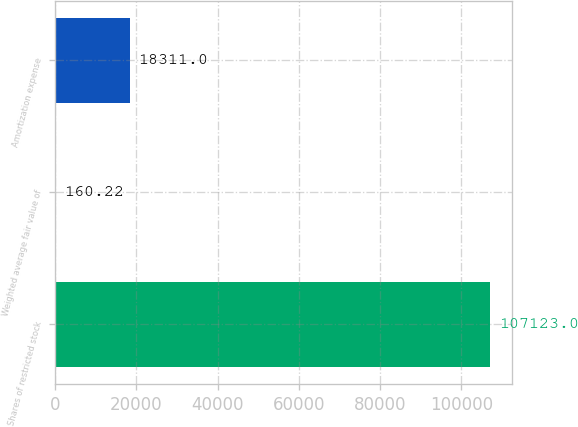<chart> <loc_0><loc_0><loc_500><loc_500><bar_chart><fcel>Shares of restricted stock<fcel>Weighted average fair value of<fcel>Amortization expense<nl><fcel>107123<fcel>160.22<fcel>18311<nl></chart> 